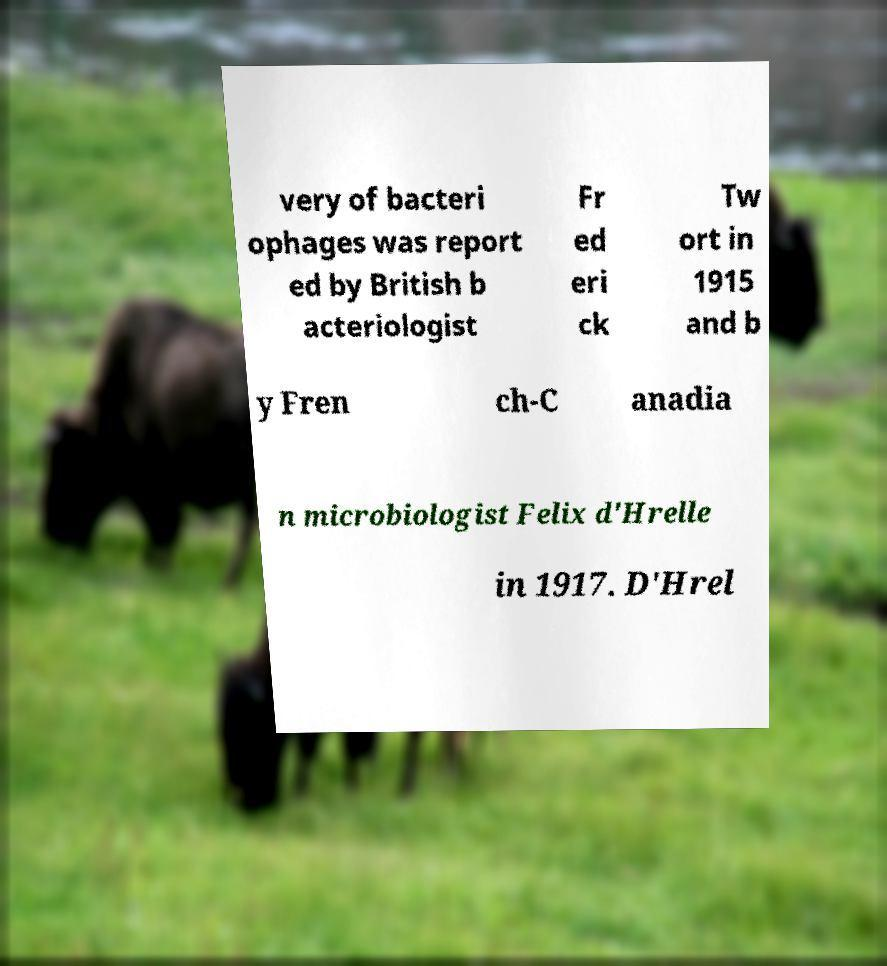Please identify and transcribe the text found in this image. very of bacteri ophages was report ed by British b acteriologist Fr ed eri ck Tw ort in 1915 and b y Fren ch-C anadia n microbiologist Felix d'Hrelle in 1917. D'Hrel 